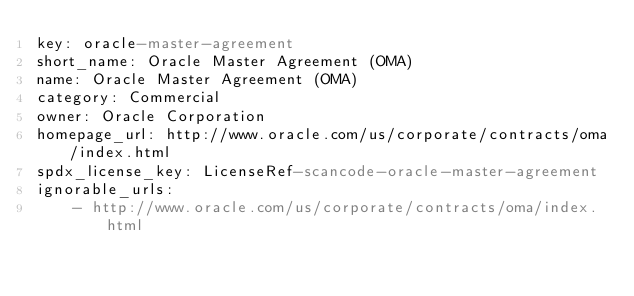Convert code to text. <code><loc_0><loc_0><loc_500><loc_500><_YAML_>key: oracle-master-agreement
short_name: Oracle Master Agreement (OMA)
name: Oracle Master Agreement (OMA)
category: Commercial
owner: Oracle Corporation
homepage_url: http://www.oracle.com/us/corporate/contracts/oma/index.html
spdx_license_key: LicenseRef-scancode-oracle-master-agreement
ignorable_urls:
    - http://www.oracle.com/us/corporate/contracts/oma/index.html
</code> 